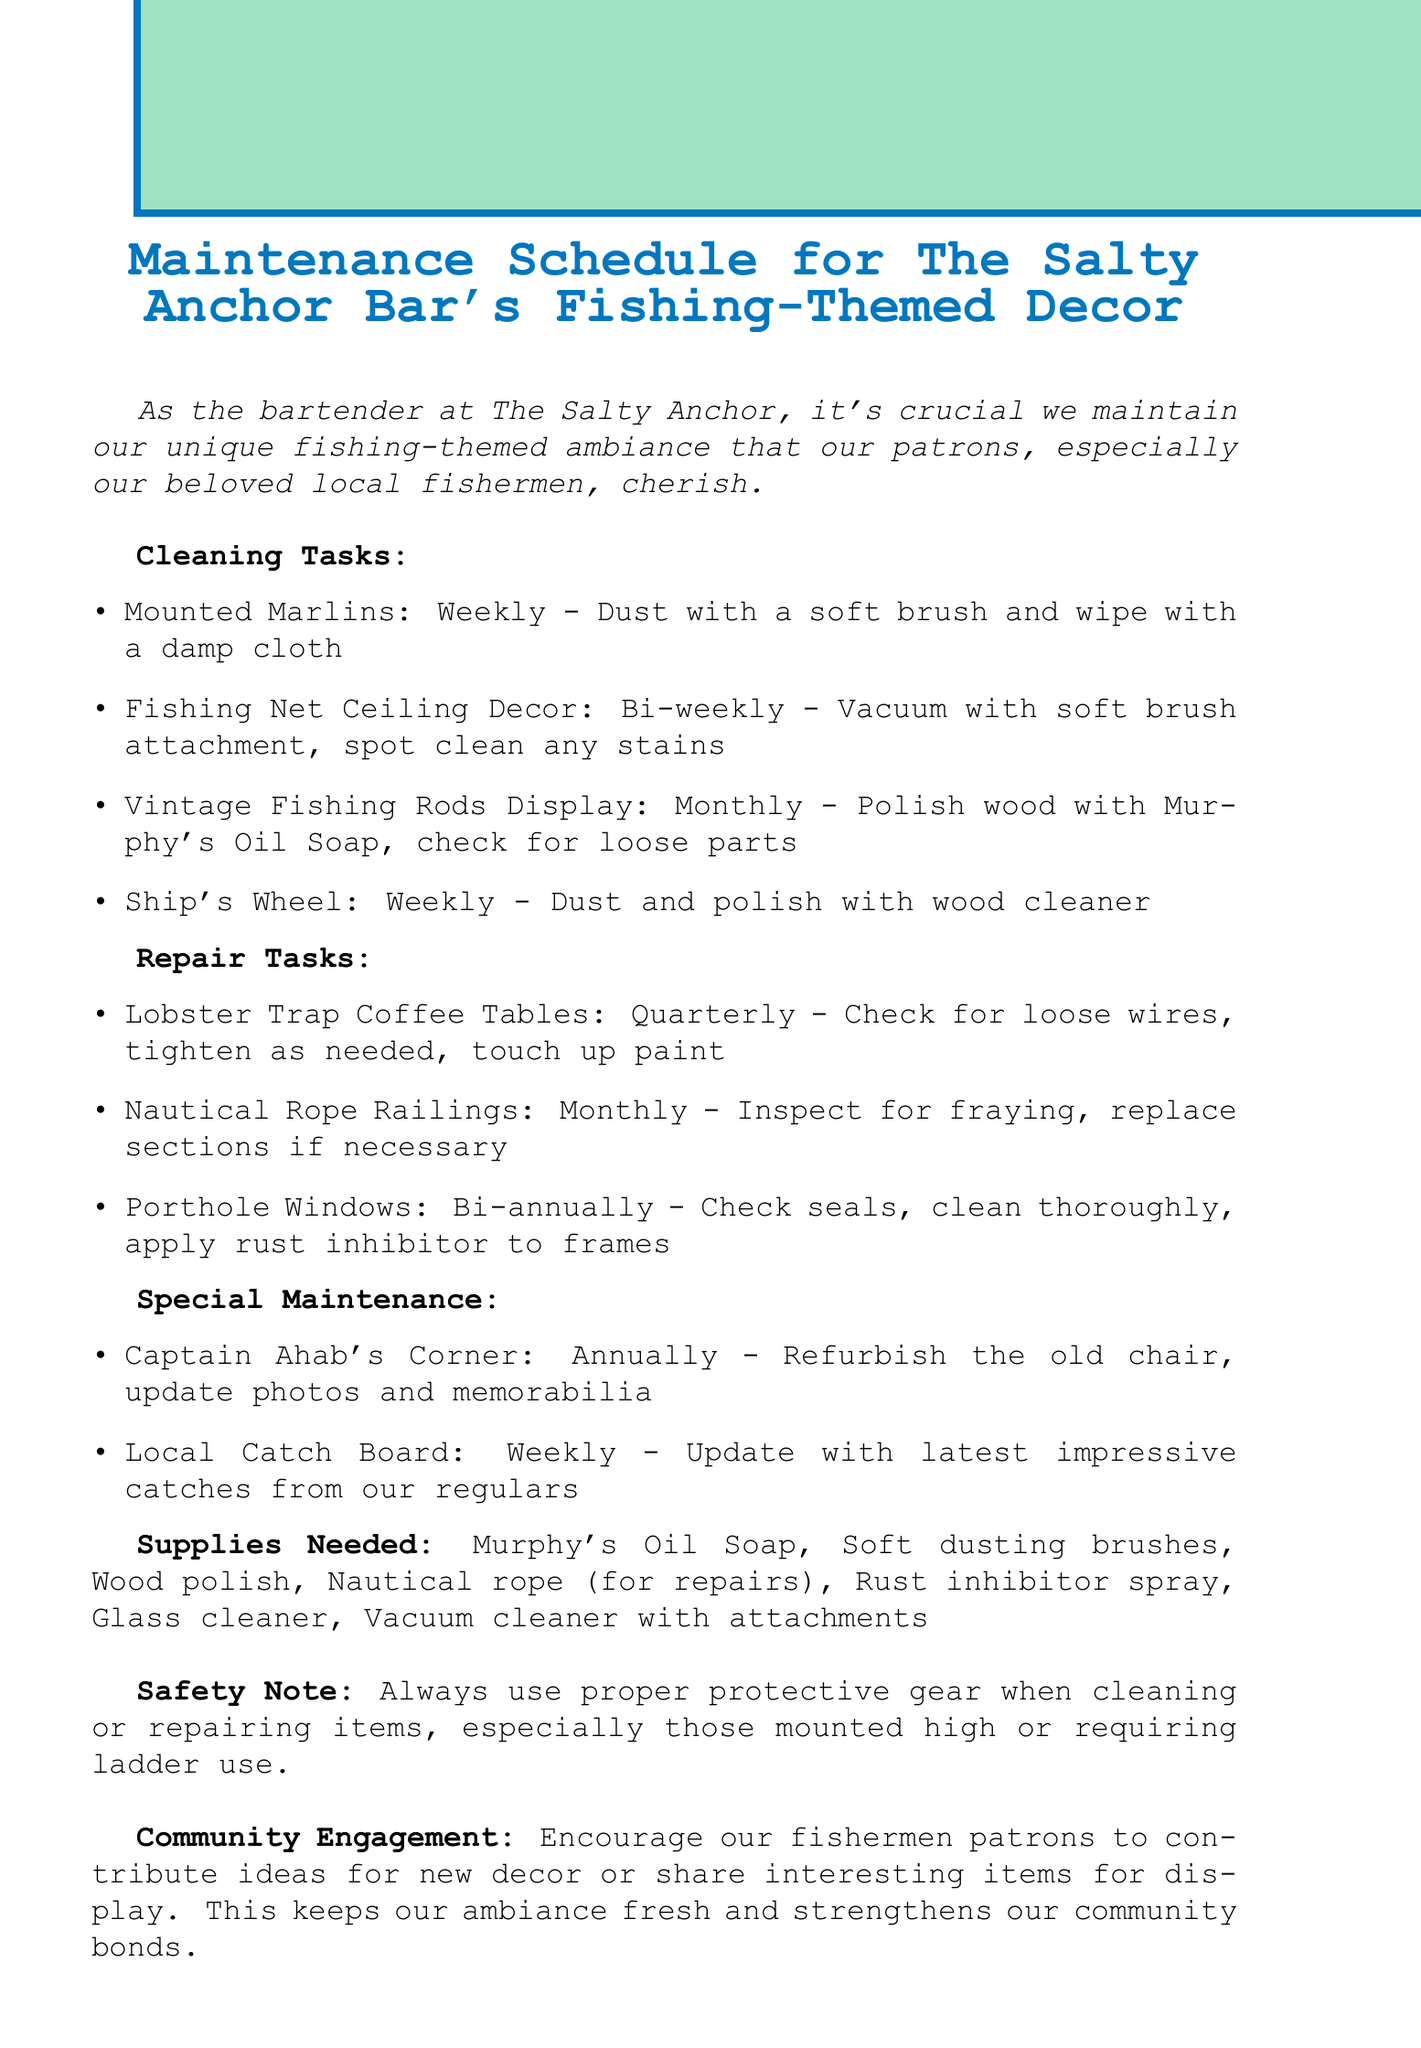what is the title of the memo? The title is explicitly stated at the beginning of the document, which outlines the purpose of the maintenance schedule.
Answer: Maintenance Schedule for The Salty Anchor Bar's Fishing-Themed Decor how often should the Vintage Fishing Rods Display be cleaned? The frequency for cleaning the Vintage Fishing Rods Display is mentioned in the cleaning tasks section.
Answer: Monthly what item requires annual special maintenance? The special maintenance section specifies items, one of which is noted for annual maintenance.
Answer: Captain Ahab's Corner how frequently should the Nautical Rope Railings be inspected? The repair tasks section outlines the frequency for each item, including the Nautical Rope Railings.
Answer: Monthly what is the purpose of the community engagement note? The document emphasizes the importance of community involvement and its impact on decor freshness and connections.
Answer: Strengthens community bonds how many items are listed under the cleaning tasks? The document details the number of cleaning tasks specified under that section.
Answer: Four what supply is needed for repairs? The supplies needed section lists various items, including one explicitly mentioned for repairs.
Answer: Nautical rope how often should the Local Catch Board be updated? The frequency for updating the Local Catch Board is clearly stated in the special maintenance section.
Answer: Weekly what is a required cleaning tool mentioned in the supplies? The supplies needed section includes various cleaning tools required for maintenance.
Answer: Vacuum cleaner with attachments 